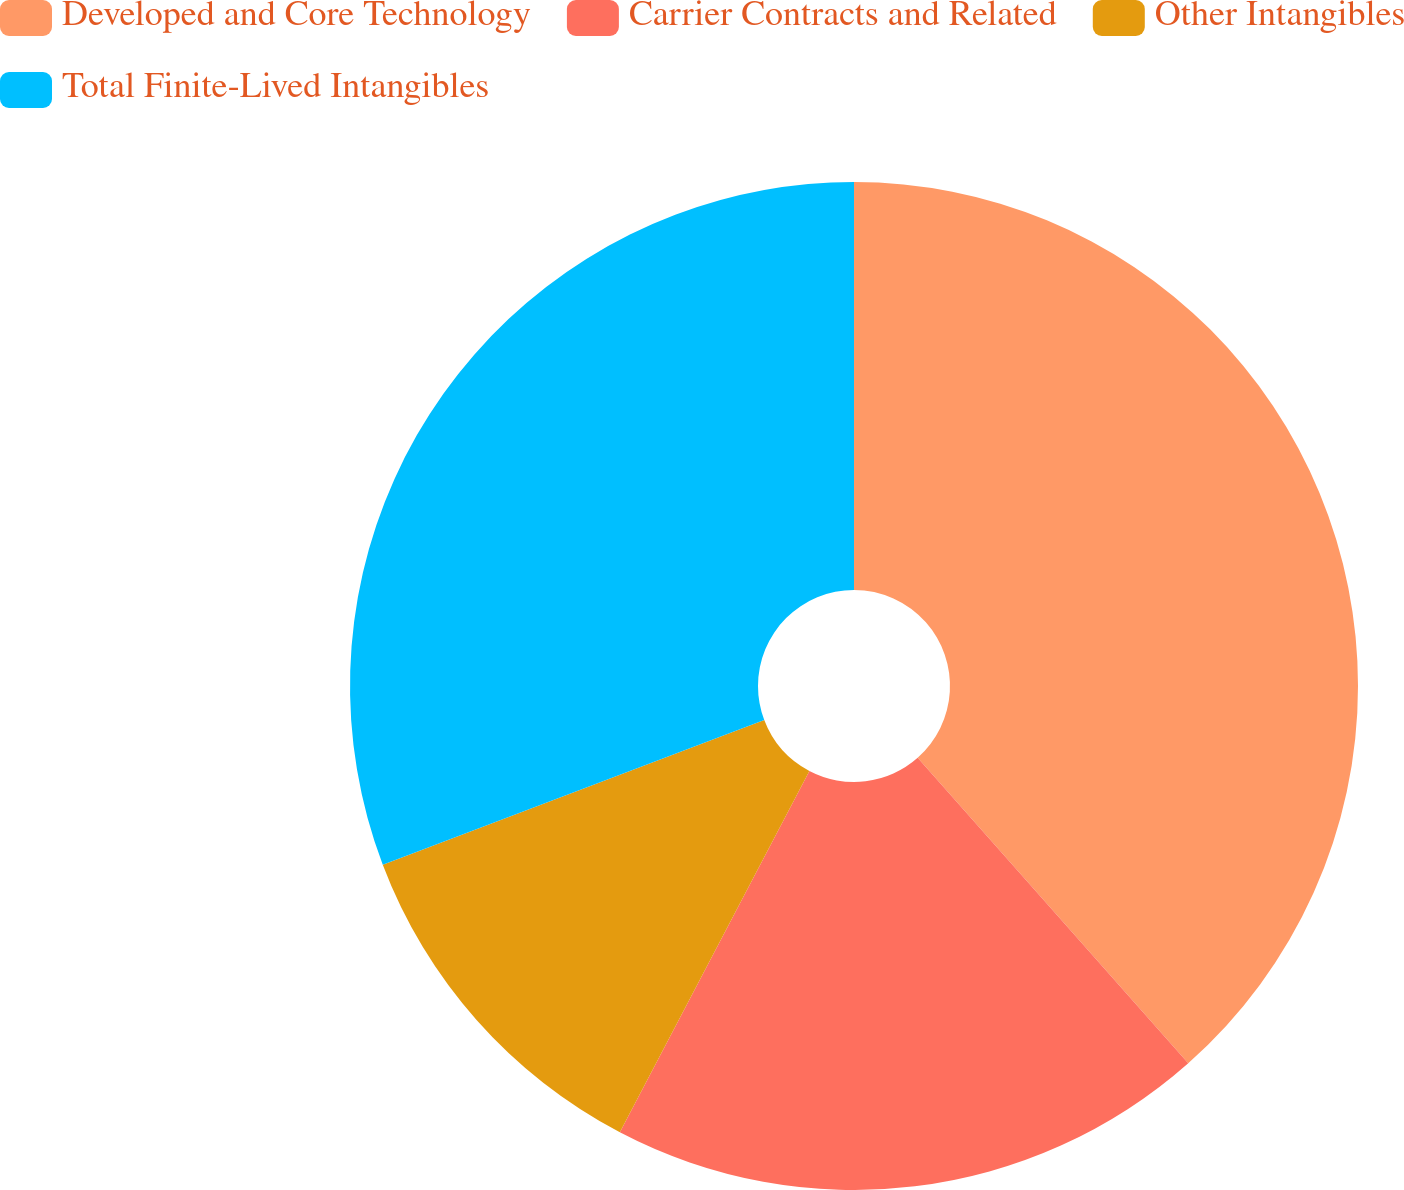<chart> <loc_0><loc_0><loc_500><loc_500><pie_chart><fcel>Developed and Core Technology<fcel>Carrier Contracts and Related<fcel>Other Intangibles<fcel>Total Finite-Lived Intangibles<nl><fcel>38.46%<fcel>19.23%<fcel>11.54%<fcel>30.77%<nl></chart> 